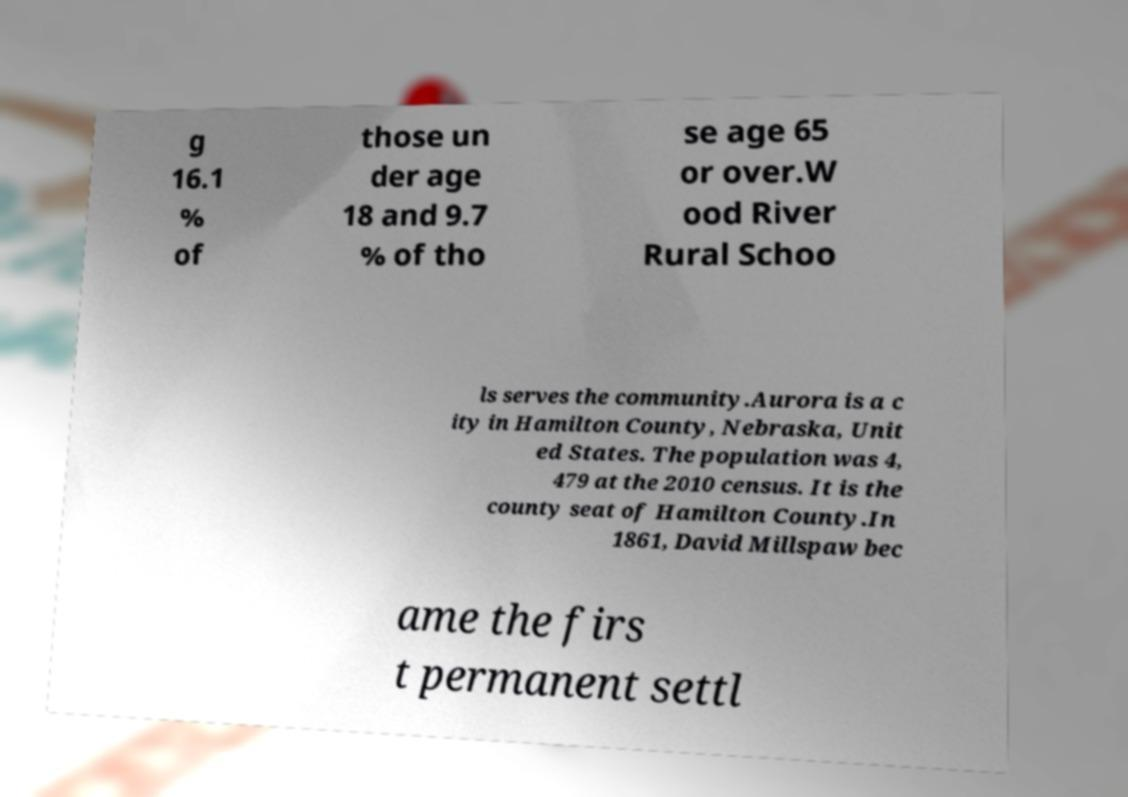There's text embedded in this image that I need extracted. Can you transcribe it verbatim? g 16.1 % of those un der age 18 and 9.7 % of tho se age 65 or over.W ood River Rural Schoo ls serves the community.Aurora is a c ity in Hamilton County, Nebraska, Unit ed States. The population was 4, 479 at the 2010 census. It is the county seat of Hamilton County.In 1861, David Millspaw bec ame the firs t permanent settl 